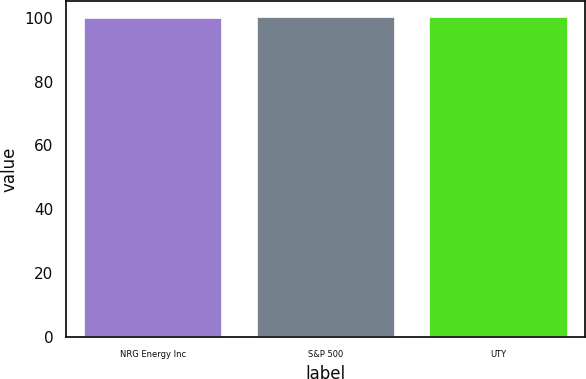Convert chart to OTSL. <chart><loc_0><loc_0><loc_500><loc_500><bar_chart><fcel>NRG Energy Inc<fcel>S&P 500<fcel>UTY<nl><fcel>100<fcel>100.1<fcel>100.2<nl></chart> 